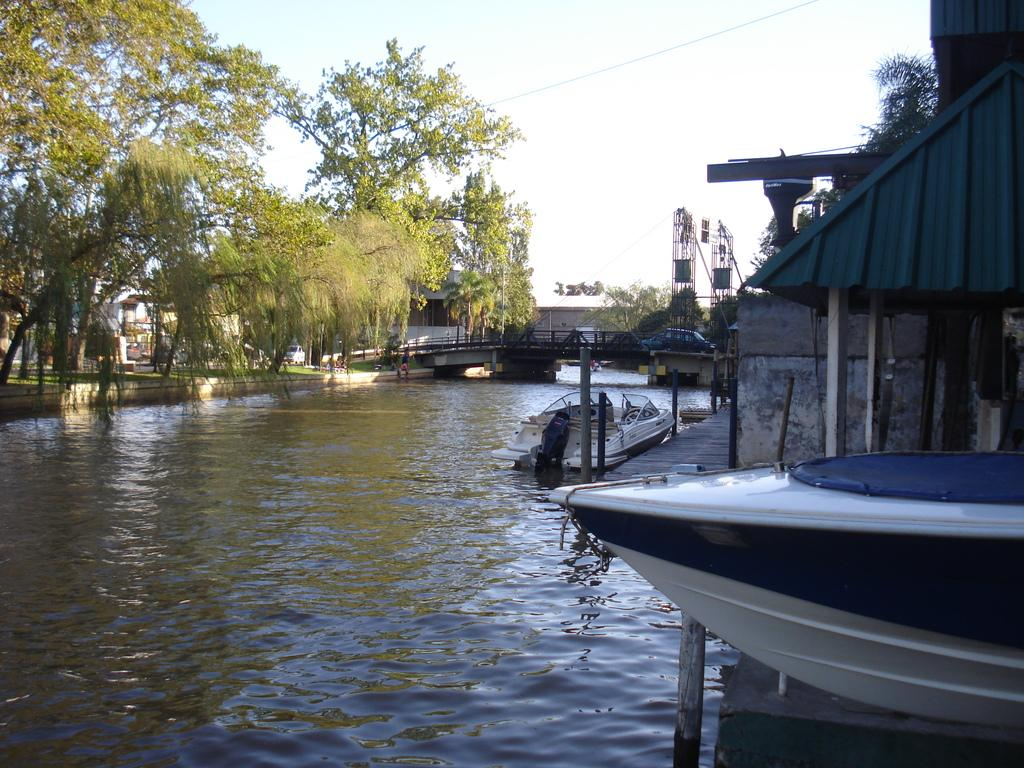What is the main feature of the image? The main feature of the image is water. What is on the water in the image? There are boats on the water in the image. What can be seen in the background of the image? There are trees and a bridge in the background of the image. What is on the bridge in the image? There is a car on the bridge in the image. What is visible at the top of the image? The sky is visible at the top of the image. What word is written on the side of the boat in the image? There is no word written on the side of the boat in the image. What type of wind can be seen blowing through the image? There is no wind visible in the image, and the term "zephyr" refers to a gentle breeze, which cannot be seen. 